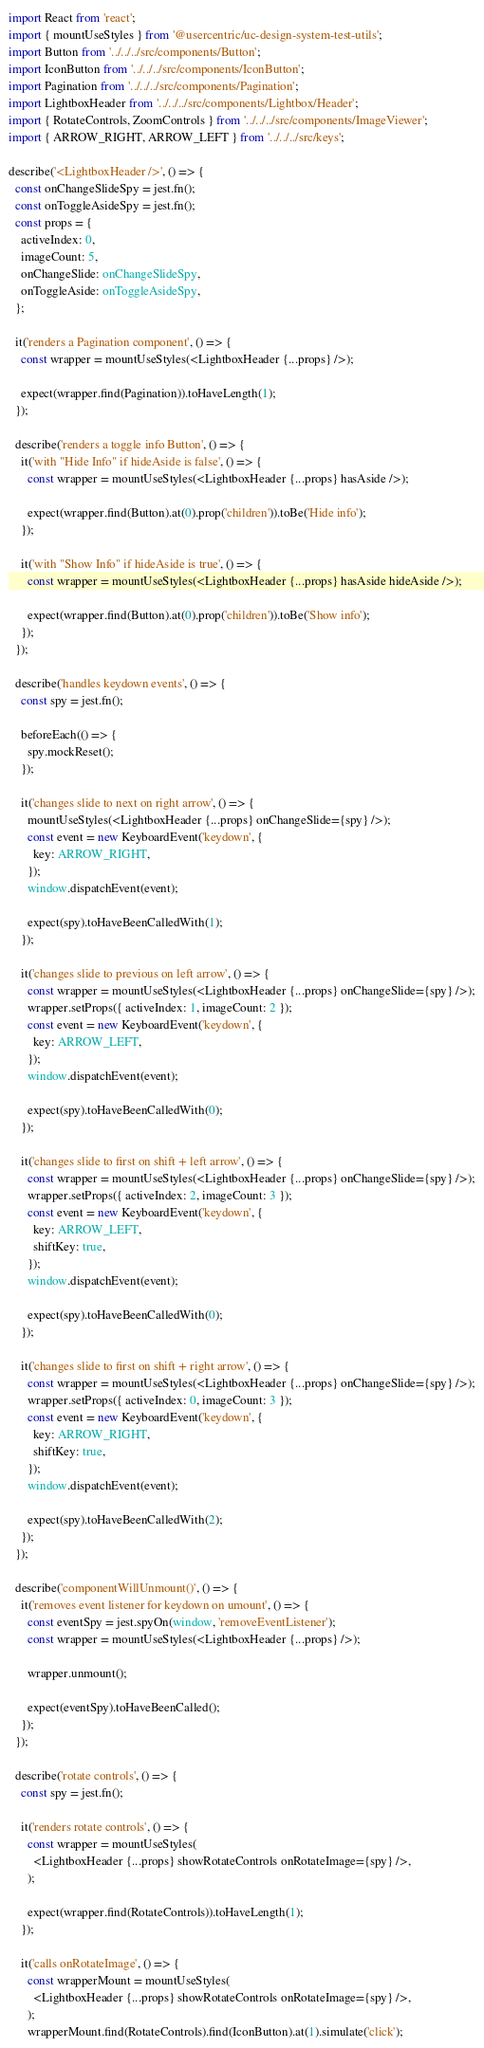<code> <loc_0><loc_0><loc_500><loc_500><_TypeScript_>import React from 'react';
import { mountUseStyles } from '@usercentric/uc-design-system-test-utils';
import Button from '../../../src/components/Button';
import IconButton from '../../../src/components/IconButton';
import Pagination from '../../../src/components/Pagination';
import LightboxHeader from '../../../src/components/Lightbox/Header';
import { RotateControls, ZoomControls } from '../../../src/components/ImageViewer';
import { ARROW_RIGHT, ARROW_LEFT } from '../../../src/keys';

describe('<LightboxHeader />', () => {
  const onChangeSlideSpy = jest.fn();
  const onToggleAsideSpy = jest.fn();
  const props = {
    activeIndex: 0,
    imageCount: 5,
    onChangeSlide: onChangeSlideSpy,
    onToggleAside: onToggleAsideSpy,
  };

  it('renders a Pagination component', () => {
    const wrapper = mountUseStyles(<LightboxHeader {...props} />);

    expect(wrapper.find(Pagination)).toHaveLength(1);
  });

  describe('renders a toggle info Button', () => {
    it('with "Hide Info" if hideAside is false', () => {
      const wrapper = mountUseStyles(<LightboxHeader {...props} hasAside />);

      expect(wrapper.find(Button).at(0).prop('children')).toBe('Hide info');
    });

    it('with "Show Info" if hideAside is true', () => {
      const wrapper = mountUseStyles(<LightboxHeader {...props} hasAside hideAside />);

      expect(wrapper.find(Button).at(0).prop('children')).toBe('Show info');
    });
  });

  describe('handles keydown events', () => {
    const spy = jest.fn();

    beforeEach(() => {
      spy.mockReset();
    });

    it('changes slide to next on right arrow', () => {
      mountUseStyles(<LightboxHeader {...props} onChangeSlide={spy} />);
      const event = new KeyboardEvent('keydown', {
        key: ARROW_RIGHT,
      });
      window.dispatchEvent(event);

      expect(spy).toHaveBeenCalledWith(1);
    });

    it('changes slide to previous on left arrow', () => {
      const wrapper = mountUseStyles(<LightboxHeader {...props} onChangeSlide={spy} />);
      wrapper.setProps({ activeIndex: 1, imageCount: 2 });
      const event = new KeyboardEvent('keydown', {
        key: ARROW_LEFT,
      });
      window.dispatchEvent(event);

      expect(spy).toHaveBeenCalledWith(0);
    });

    it('changes slide to first on shift + left arrow', () => {
      const wrapper = mountUseStyles(<LightboxHeader {...props} onChangeSlide={spy} />);
      wrapper.setProps({ activeIndex: 2, imageCount: 3 });
      const event = new KeyboardEvent('keydown', {
        key: ARROW_LEFT,
        shiftKey: true,
      });
      window.dispatchEvent(event);

      expect(spy).toHaveBeenCalledWith(0);
    });

    it('changes slide to first on shift + right arrow', () => {
      const wrapper = mountUseStyles(<LightboxHeader {...props} onChangeSlide={spy} />);
      wrapper.setProps({ activeIndex: 0, imageCount: 3 });
      const event = new KeyboardEvent('keydown', {
        key: ARROW_RIGHT,
        shiftKey: true,
      });
      window.dispatchEvent(event);

      expect(spy).toHaveBeenCalledWith(2);
    });
  });

  describe('componentWillUnmount()', () => {
    it('removes event listener for keydown on umount', () => {
      const eventSpy = jest.spyOn(window, 'removeEventListener');
      const wrapper = mountUseStyles(<LightboxHeader {...props} />);

      wrapper.unmount();

      expect(eventSpy).toHaveBeenCalled();
    });
  });

  describe('rotate controls', () => {
    const spy = jest.fn();

    it('renders rotate controls', () => {
      const wrapper = mountUseStyles(
        <LightboxHeader {...props} showRotateControls onRotateImage={spy} />,
      );

      expect(wrapper.find(RotateControls)).toHaveLength(1);
    });

    it('calls onRotateImage', () => {
      const wrapperMount = mountUseStyles(
        <LightboxHeader {...props} showRotateControls onRotateImage={spy} />,
      );
      wrapperMount.find(RotateControls).find(IconButton).at(1).simulate('click');
</code> 